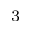Convert formula to latex. <formula><loc_0><loc_0><loc_500><loc_500>^ { 3 }</formula> 